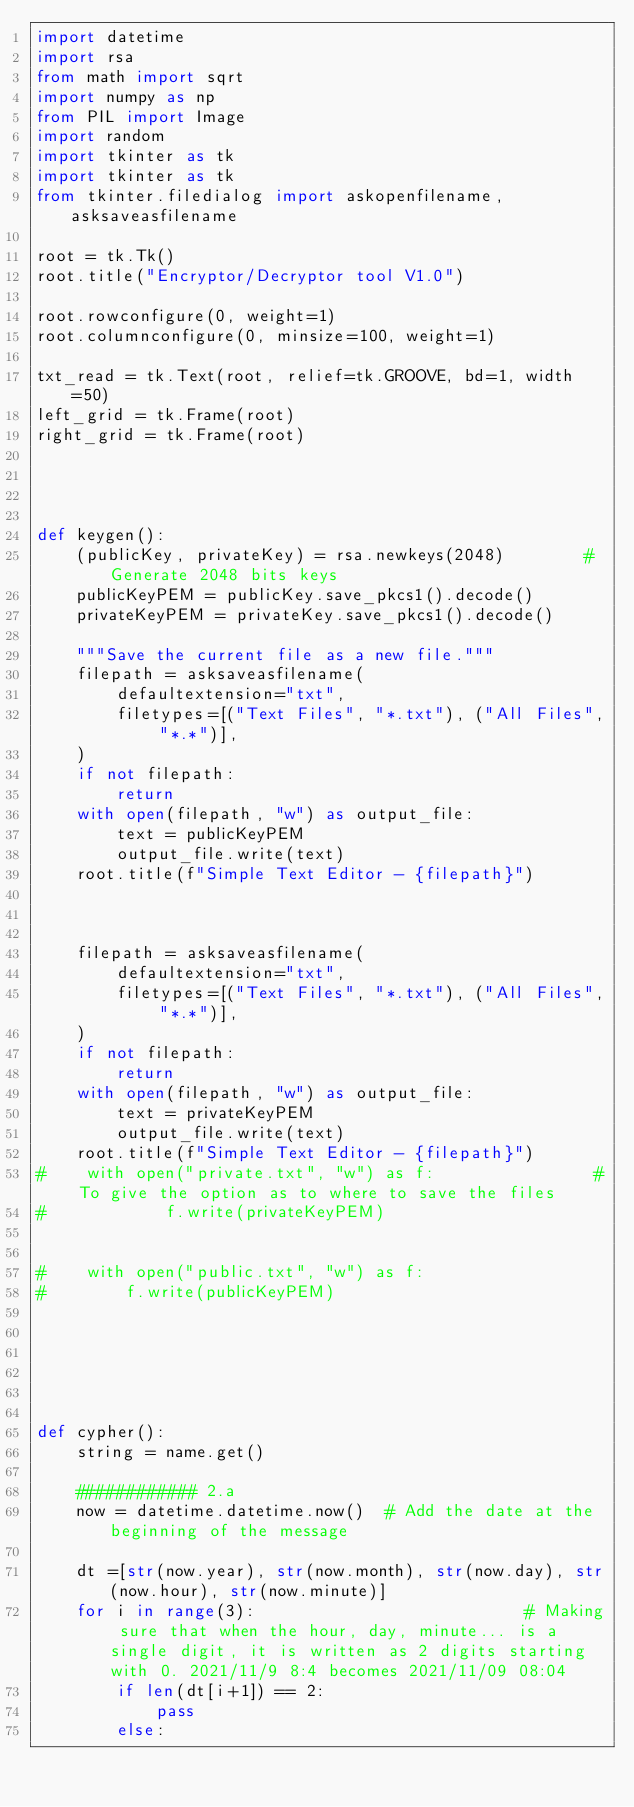Convert code to text. <code><loc_0><loc_0><loc_500><loc_500><_Python_>import datetime
import rsa
from math import sqrt
import numpy as np
from PIL import Image
import random
import tkinter as tk
import tkinter as tk
from tkinter.filedialog import askopenfilename, asksaveasfilename

root = tk.Tk()
root.title("Encryptor/Decryptor tool V1.0")

root.rowconfigure(0, weight=1)
root.columnconfigure(0, minsize=100, weight=1)

txt_read = tk.Text(root, relief=tk.GROOVE, bd=1, width=50)
left_grid = tk.Frame(root)
right_grid = tk.Frame(root)




def keygen():
    (publicKey, privateKey) = rsa.newkeys(2048)        # Generate 2048 bits keys
    publicKeyPEM = publicKey.save_pkcs1().decode()
    privateKeyPEM = privateKey.save_pkcs1().decode()

    """Save the current file as a new file."""
    filepath = asksaveasfilename(
        defaultextension="txt",
        filetypes=[("Text Files", "*.txt"), ("All Files", "*.*")],
    )
    if not filepath:
        return
    with open(filepath, "w") as output_file:
        text = publicKeyPEM
        output_file.write(text)
    root.title(f"Simple Text Editor - {filepath}")



    filepath = asksaveasfilename(
        defaultextension="txt",
        filetypes=[("Text Files", "*.txt"), ("All Files", "*.*")],
    )
    if not filepath:
        return
    with open(filepath, "w") as output_file:
        text = privateKeyPEM
        output_file.write(text)
    root.title(f"Simple Text Editor - {filepath}")
#    with open("private.txt", "w") as f:                # To give the option as to where to save the files
#            f.write(privateKeyPEM)


#    with open("public.txt", "w") as f:
#        f.write(publicKeyPEM)






def cypher():
    string = name.get()

    ############ 2.a
    now = datetime.datetime.now()  # Add the date at the beginning of the message

    dt =[str(now.year), str(now.month), str(now.day), str(now.hour), str(now.minute)]
    for i in range(3):                           # Making sure that when the hour, day, minute... is a single digit, it is written as 2 digits starting with 0. 2021/11/9 8:4 becomes 2021/11/09 08:04
        if len(dt[i+1]) == 2:
            pass
        else:</code> 